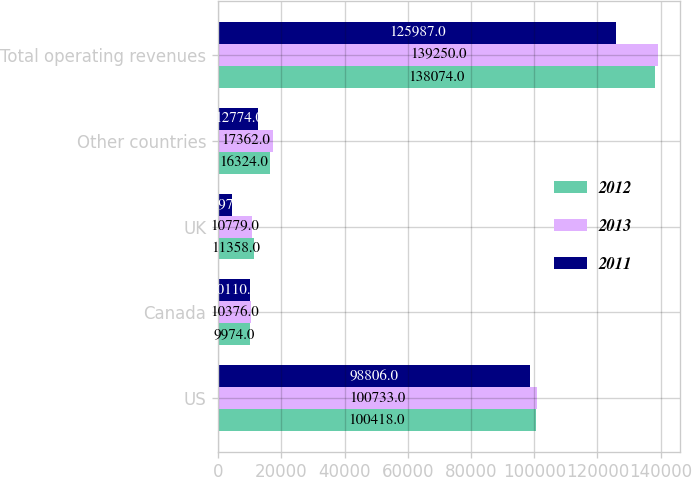Convert chart. <chart><loc_0><loc_0><loc_500><loc_500><stacked_bar_chart><ecel><fcel>US<fcel>Canada<fcel>UK<fcel>Other countries<fcel>Total operating revenues<nl><fcel>2012<fcel>100418<fcel>9974<fcel>11358<fcel>16324<fcel>138074<nl><fcel>2013<fcel>100733<fcel>10376<fcel>10779<fcel>17362<fcel>139250<nl><fcel>2011<fcel>98806<fcel>10110<fcel>4297<fcel>12774<fcel>125987<nl></chart> 